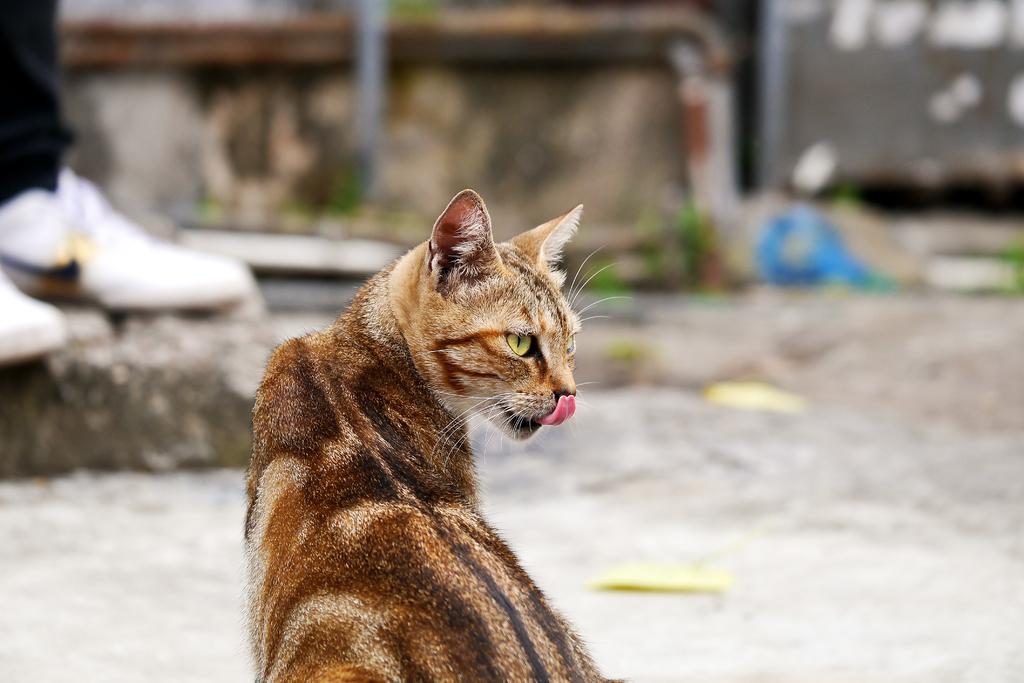What is the main subject of the image? A: The main subject of the image is a car. Can you describe the colors of the car? The car has black, brown, and white colors. What is located on the back side of the car? There is a rock on the back side of the car. What is on top of the rock? A white shoe is on the rock. How would you describe the background of the image? The background of the image is blurred. What type of pie is being served at the car dealership in the image? There is no pie or car dealership present in the image; it features a car with a rock and a white shoe on it. What is the profit margin for the car manufacturer in the image? There is no information about profit margins or car manufacturers in the image. 